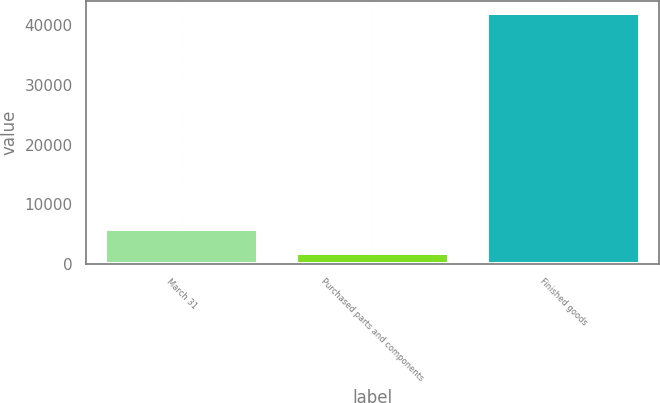Convert chart to OTSL. <chart><loc_0><loc_0><loc_500><loc_500><bar_chart><fcel>March 31<fcel>Purchased parts and components<fcel>Finished goods<nl><fcel>5896.8<fcel>1885<fcel>42003<nl></chart> 